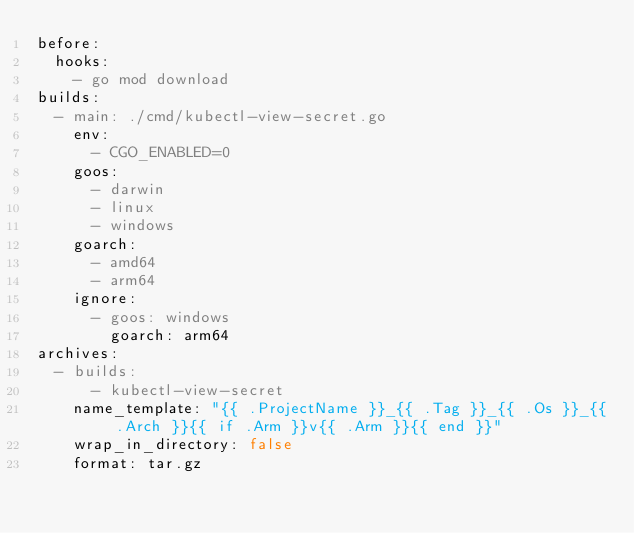Convert code to text. <code><loc_0><loc_0><loc_500><loc_500><_YAML_>before:
  hooks:
    - go mod download
builds:
  - main: ./cmd/kubectl-view-secret.go
    env:
      - CGO_ENABLED=0
    goos:
      - darwin
      - linux
      - windows
    goarch:
      - amd64
      - arm64
    ignore:
      - goos: windows
        goarch: arm64
archives:
  - builds:
      - kubectl-view-secret
    name_template: "{{ .ProjectName }}_{{ .Tag }}_{{ .Os }}_{{ .Arch }}{{ if .Arm }}v{{ .Arm }}{{ end }}"
    wrap_in_directory: false
    format: tar.gz
</code> 